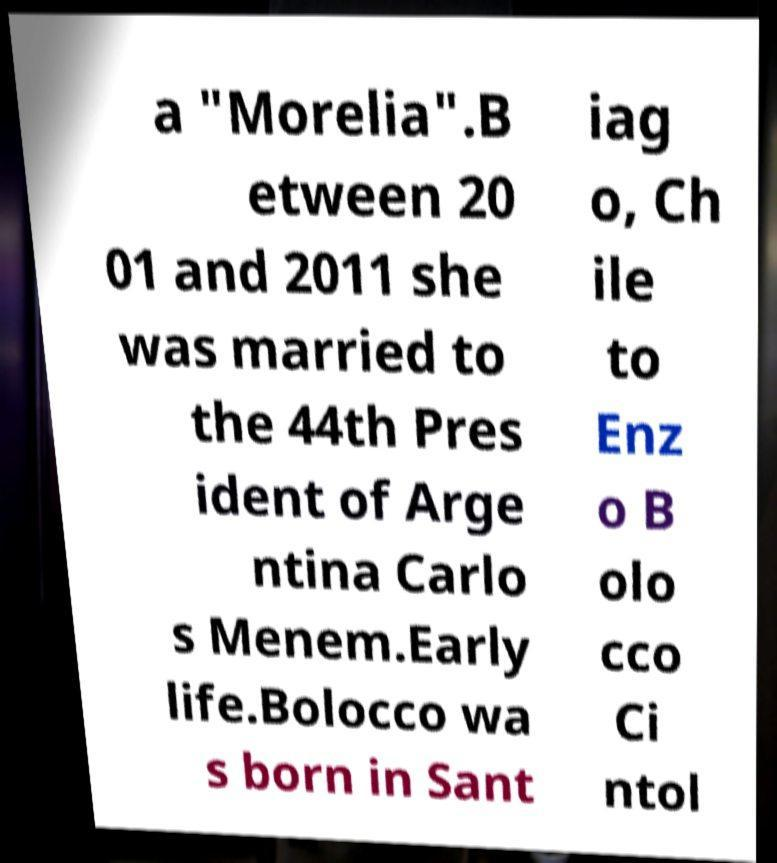Please read and relay the text visible in this image. What does it say? a "Morelia".B etween 20 01 and 2011 she was married to the 44th Pres ident of Arge ntina Carlo s Menem.Early life.Bolocco wa s born in Sant iag o, Ch ile to Enz o B olo cco Ci ntol 